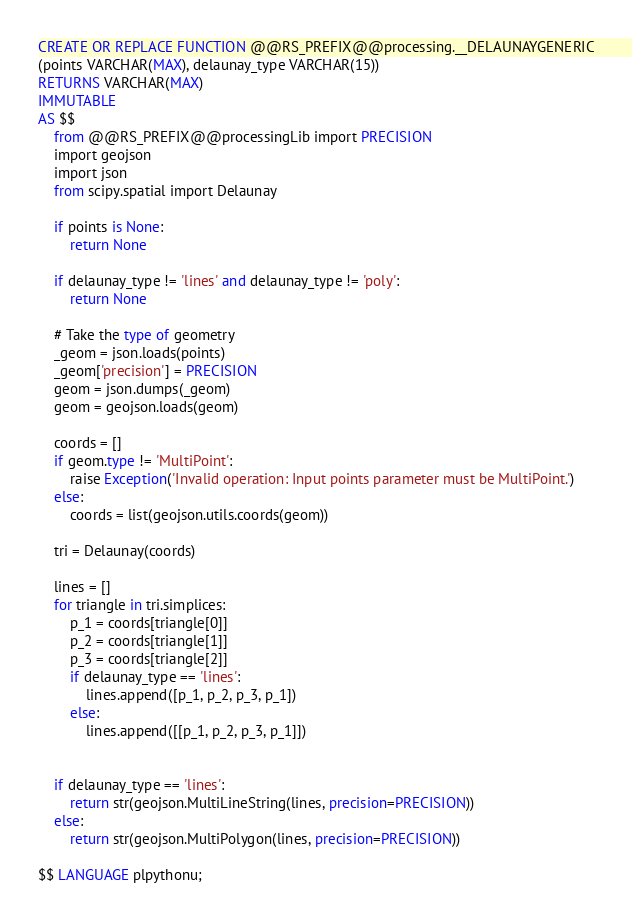<code> <loc_0><loc_0><loc_500><loc_500><_SQL_>
CREATE OR REPLACE FUNCTION @@RS_PREFIX@@processing.__DELAUNAYGENERIC
(points VARCHAR(MAX), delaunay_type VARCHAR(15))
RETURNS VARCHAR(MAX)
IMMUTABLE
AS $$
    from @@RS_PREFIX@@processingLib import PRECISION
    import geojson
    import json
    from scipy.spatial import Delaunay

    if points is None:
        return None

    if delaunay_type != 'lines' and delaunay_type != 'poly':
        return None
 
    # Take the type of geometry
    _geom = json.loads(points)
    _geom['precision'] = PRECISION
    geom = json.dumps(_geom)
    geom = geojson.loads(geom)
    
    coords = []
    if geom.type != 'MultiPoint':
        raise Exception('Invalid operation: Input points parameter must be MultiPoint.')
    else:
        coords = list(geojson.utils.coords(geom))

    tri = Delaunay(coords)

    lines = []
    for triangle in tri.simplices:
        p_1 = coords[triangle[0]]
        p_2 = coords[triangle[1]]
        p_3 = coords[triangle[2]]
        if delaunay_type == 'lines':
            lines.append([p_1, p_2, p_3, p_1])
        else:
            lines.append([[p_1, p_2, p_3, p_1]])

            
    if delaunay_type == 'lines':
        return str(geojson.MultiLineString(lines, precision=PRECISION))
    else:
        return str(geojson.MultiPolygon(lines, precision=PRECISION))

$$ LANGUAGE plpythonu;</code> 